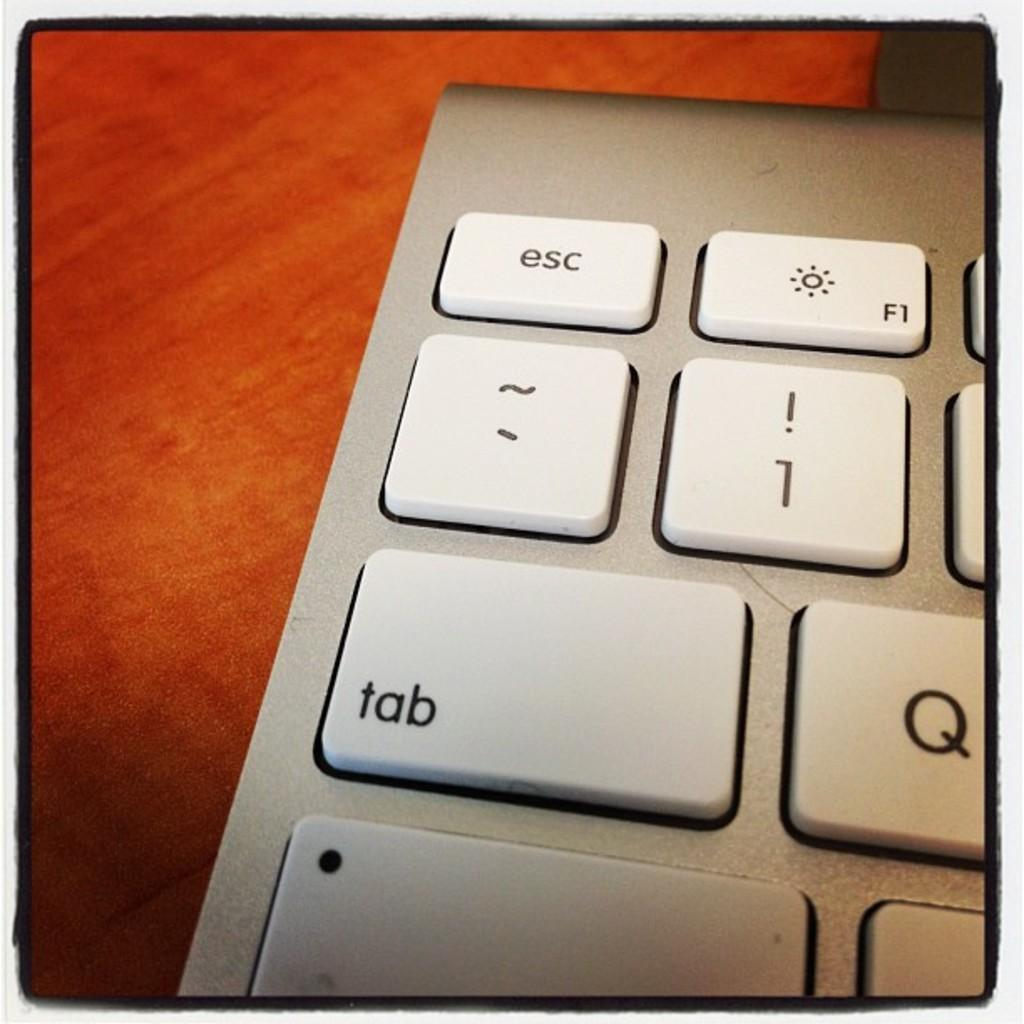<image>
Describe the image concisely. a close up of a silver key board with keys for ESC and TAB 